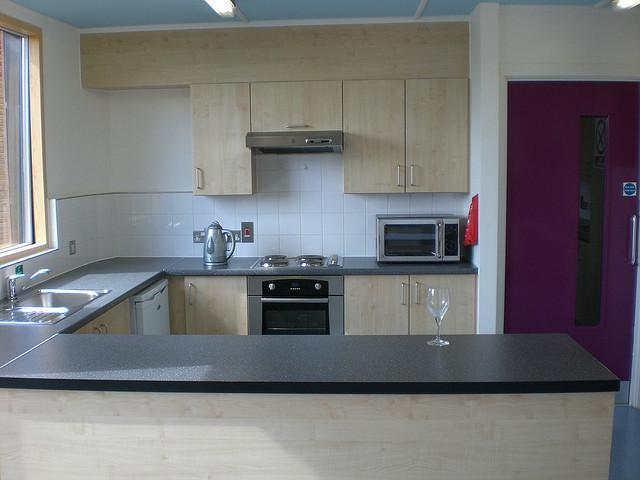How many glasses are on the counter?
Give a very brief answer. 1. 